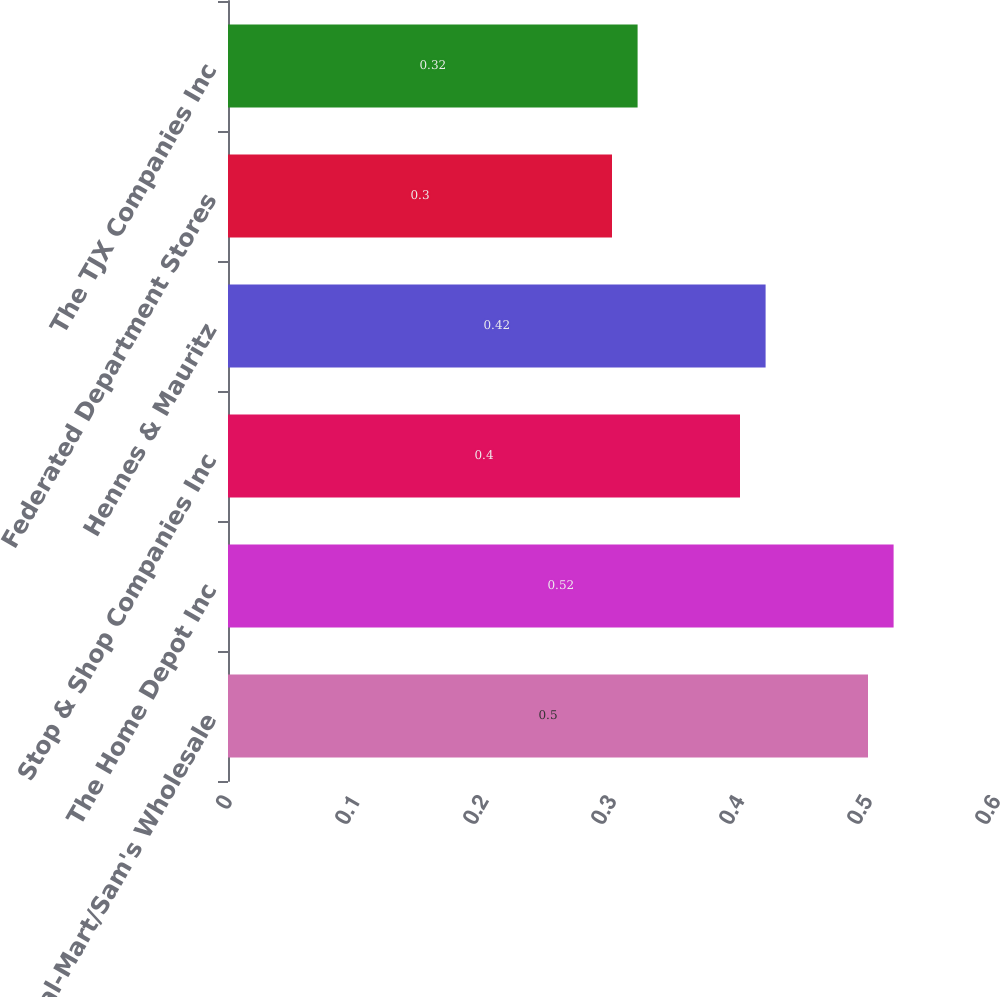Convert chart to OTSL. <chart><loc_0><loc_0><loc_500><loc_500><bar_chart><fcel>Wal-Mart/Sam's Wholesale<fcel>The Home Depot Inc<fcel>Stop & Shop Companies Inc<fcel>Hennes & Mauritz<fcel>Federated Department Stores<fcel>The TJX Companies Inc<nl><fcel>0.5<fcel>0.52<fcel>0.4<fcel>0.42<fcel>0.3<fcel>0.32<nl></chart> 